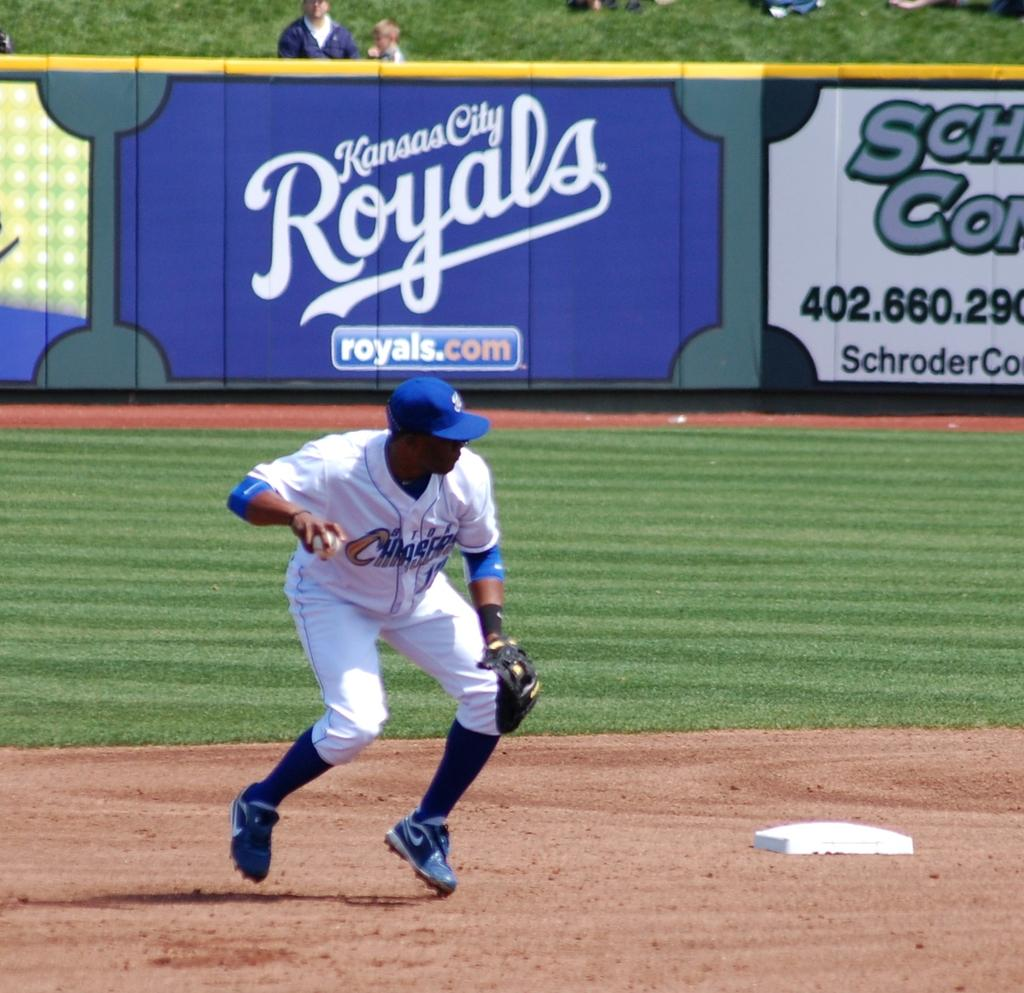Provide a one-sentence caption for the provided image. A large sign on the field for the Kansas City Royals. 